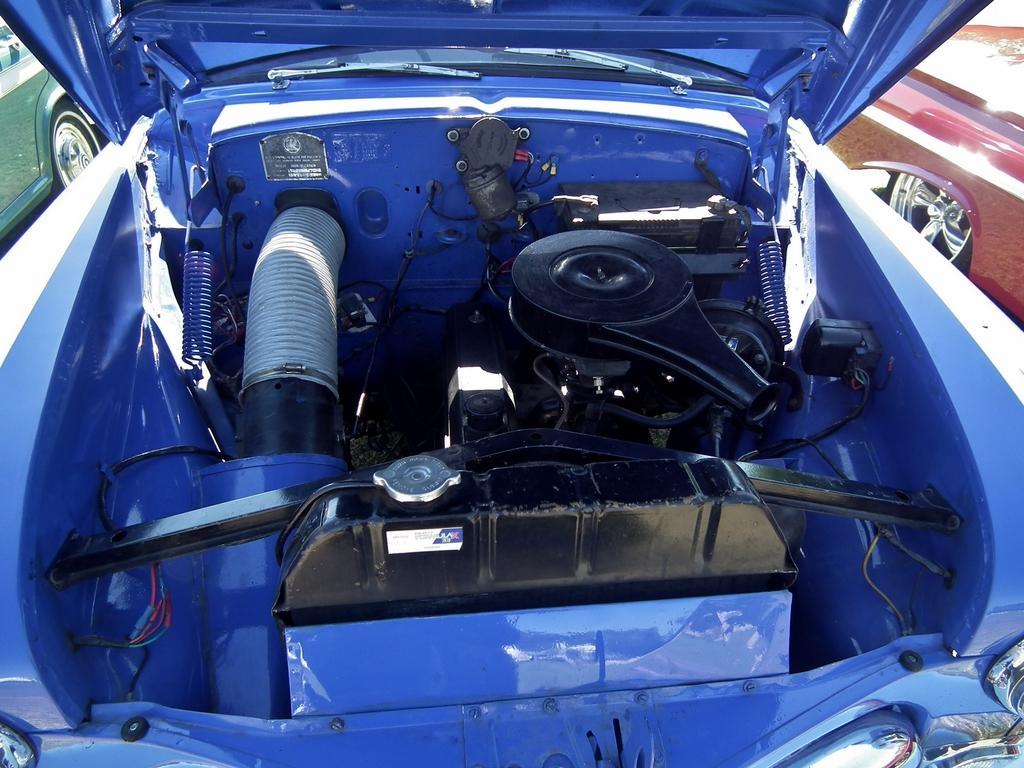Describe this image in one or two sentences. In this image there are three cars. There is a green car at the left most of the image. There is a red car at the right most of the image and blue car at the center. 